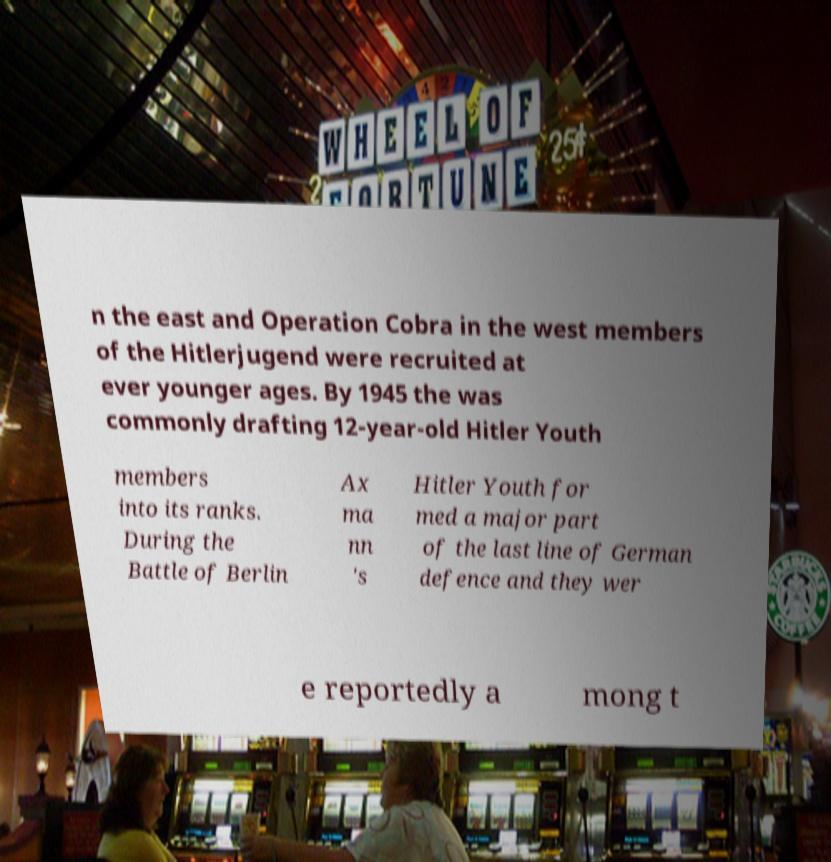Can you read and provide the text displayed in the image?This photo seems to have some interesting text. Can you extract and type it out for me? n the east and Operation Cobra in the west members of the Hitlerjugend were recruited at ever younger ages. By 1945 the was commonly drafting 12-year-old Hitler Youth members into its ranks. During the Battle of Berlin Ax ma nn 's Hitler Youth for med a major part of the last line of German defence and they wer e reportedly a mong t 